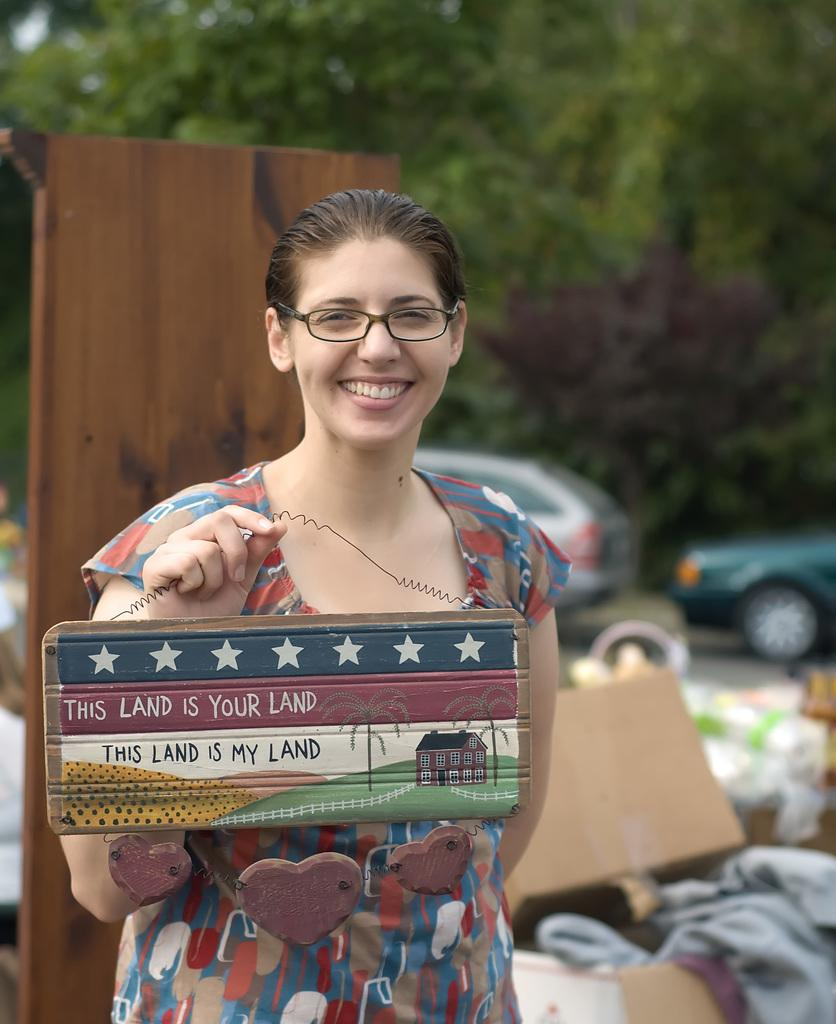What is the main subject of the image? There is a woman in the image. What is the woman holding in her hand? The woman is holding an object in her hand. Can you describe the door behind the woman? There is a tall wooden door behind the woman. How would you describe the background of the image? The background of the image is blurry. What type of harmony is the woman playing on the calculator in the image? There is no calculator or any indication of music or harmony in the image. 